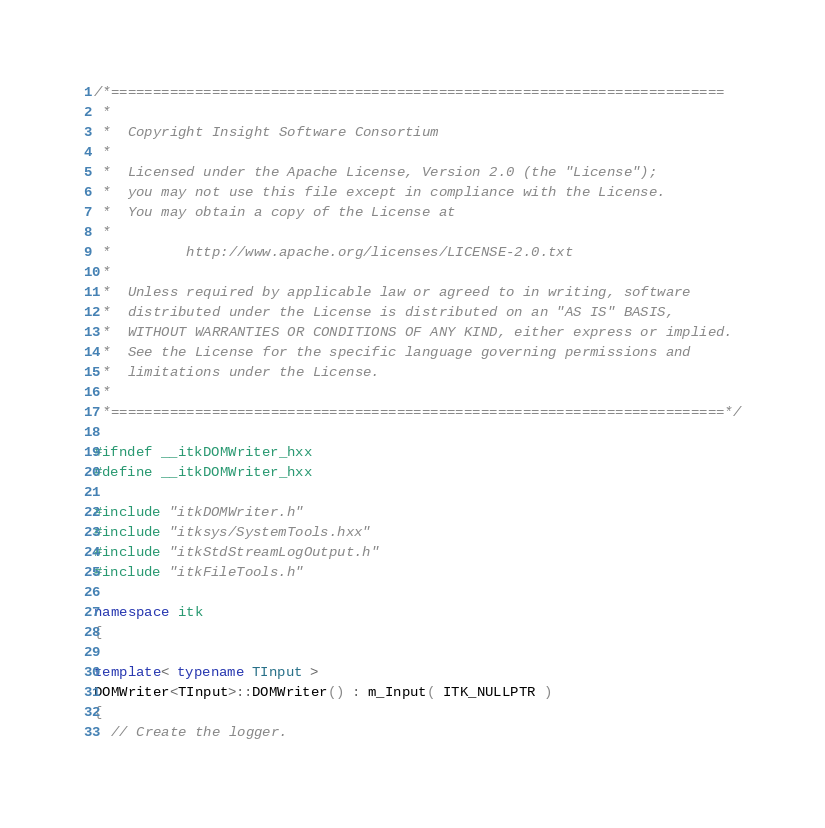Convert code to text. <code><loc_0><loc_0><loc_500><loc_500><_C++_>/*=========================================================================
 *
 *  Copyright Insight Software Consortium
 *
 *  Licensed under the Apache License, Version 2.0 (the "License");
 *  you may not use this file except in compliance with the License.
 *  You may obtain a copy of the License at
 *
 *         http://www.apache.org/licenses/LICENSE-2.0.txt
 *
 *  Unless required by applicable law or agreed to in writing, software
 *  distributed under the License is distributed on an "AS IS" BASIS,
 *  WITHOUT WARRANTIES OR CONDITIONS OF ANY KIND, either express or implied.
 *  See the License for the specific language governing permissions and
 *  limitations under the License.
 *
 *=========================================================================*/

#ifndef __itkDOMWriter_hxx
#define __itkDOMWriter_hxx

#include "itkDOMWriter.h"
#include "itksys/SystemTools.hxx"
#include "itkStdStreamLogOutput.h"
#include "itkFileTools.h"

namespace itk
{

template< typename TInput >
DOMWriter<TInput>::DOMWriter() : m_Input( ITK_NULLPTR )
{
  // Create the logger.</code> 